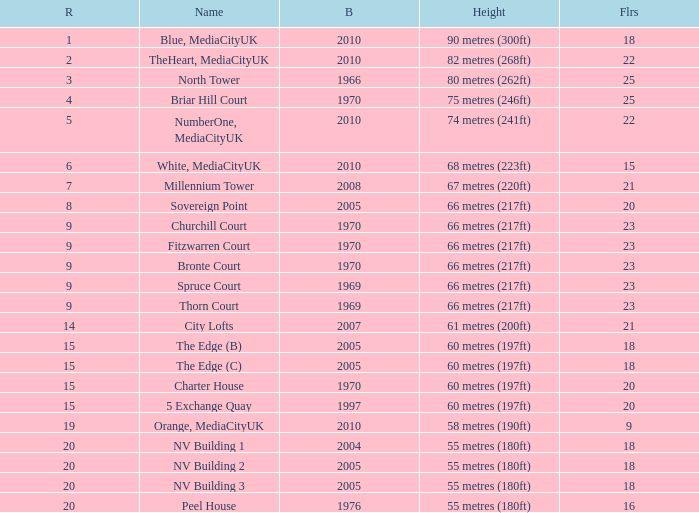What is the lowest Built, when Floors is greater than 23, and when Rank is 3? 1966.0. 